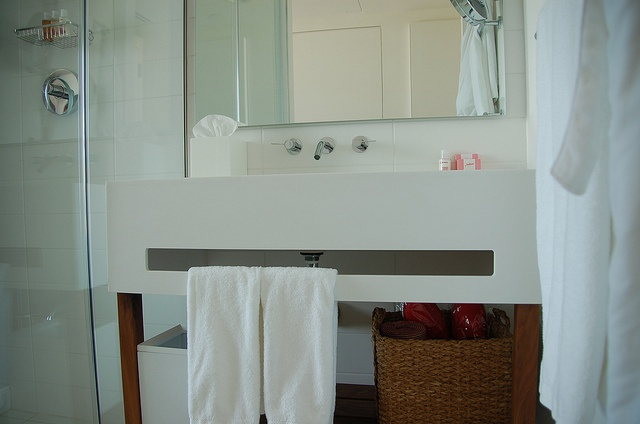Describe the objects in this image and their specific colors. I can see sink in darkgreen, darkgray, black, and gray tones and bottle in darkgreen, darkgray, lightgray, and gray tones in this image. 